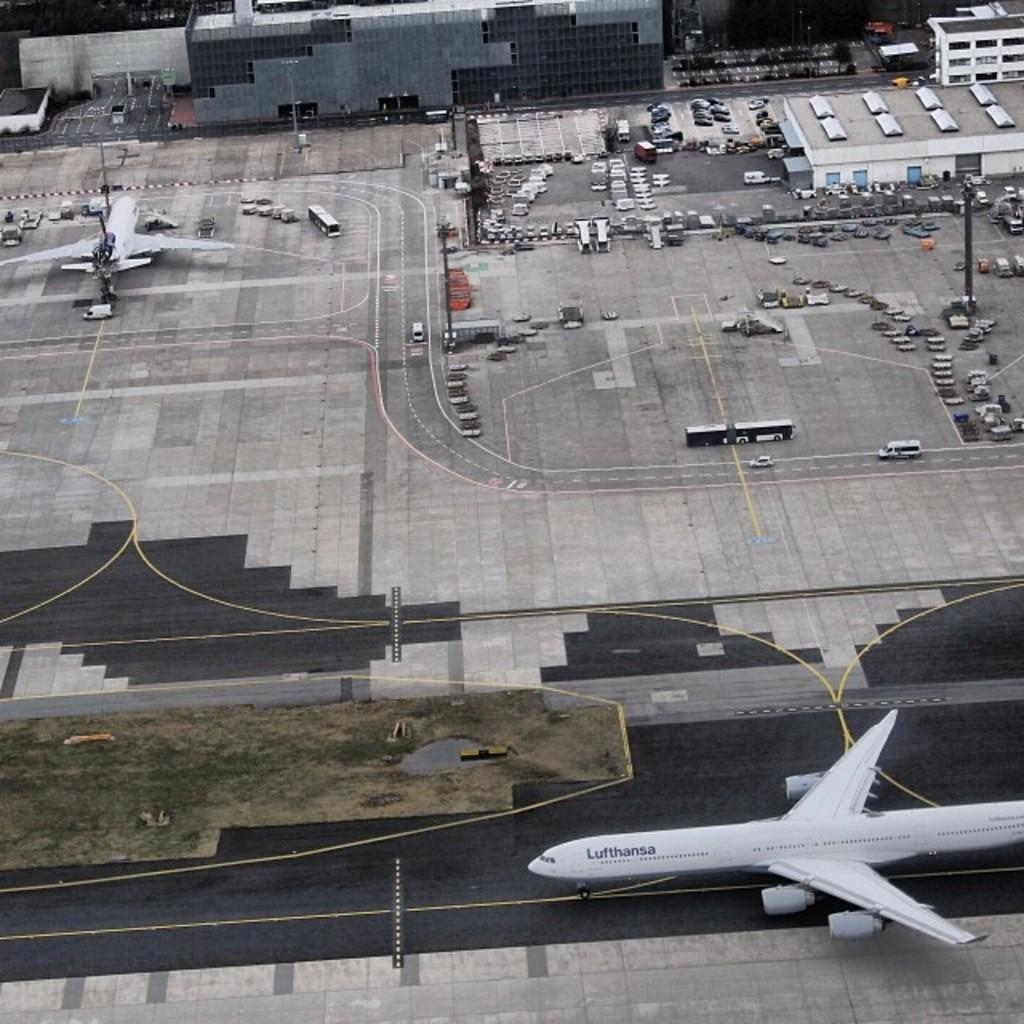What type of location is depicted in the image? The image is a top view of an airport. What can be seen on the runway in the image? There is an aeroplane on the runway. What other types of vehicles are present in the image? There are vehicles in the image. What structures can be seen in the image? There are buildings in the image. What type of natural element is visible in the image? There is grass visible in the image. What is the title of the book that the aeroplane is reading in the image? There is no book or aeroplane reading in the image; it is a top view of an airport with an aeroplane on the runway. 